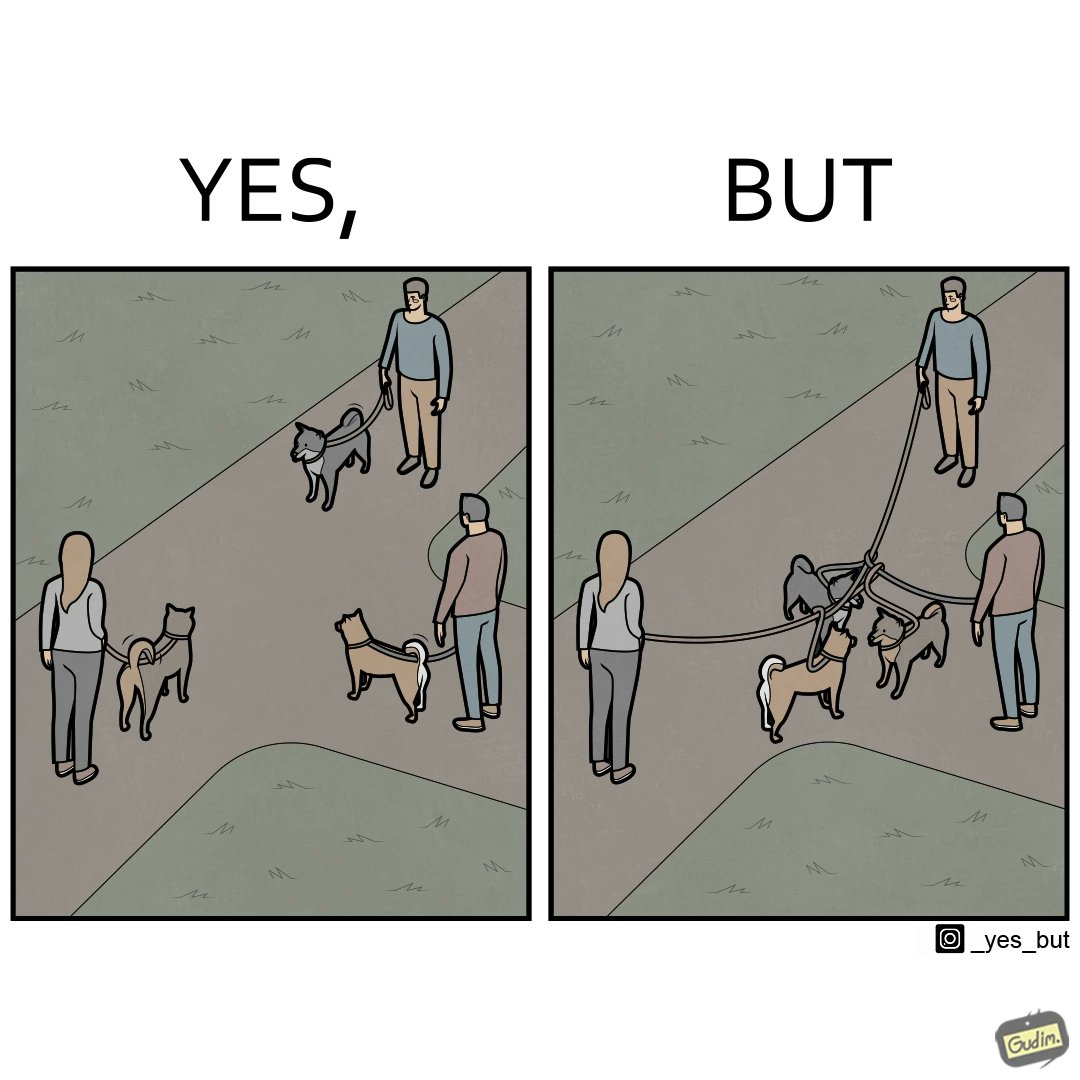What is the satirical meaning behind this image? The dog owners take their dogs for some walk in parks but their dogs mingle together with other dogs however their leashes get entangled during this which is quite inconvenient for the dog owners 